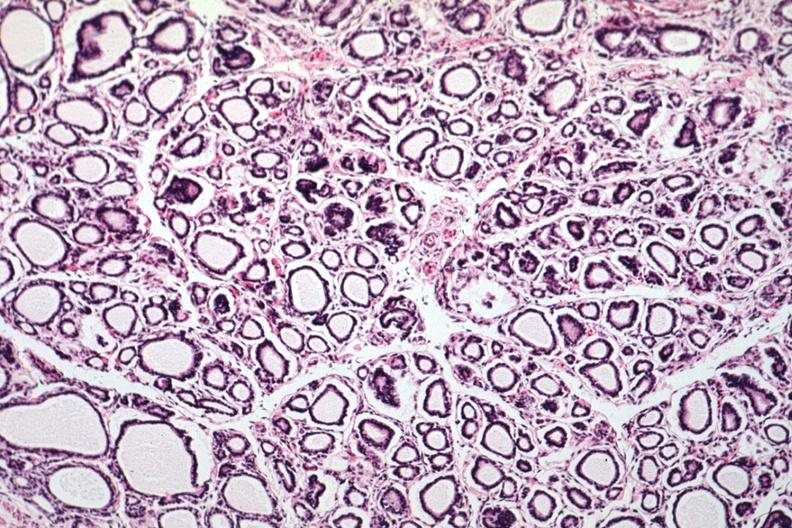s endocrine present?
Answer the question using a single word or phrase. Yes 